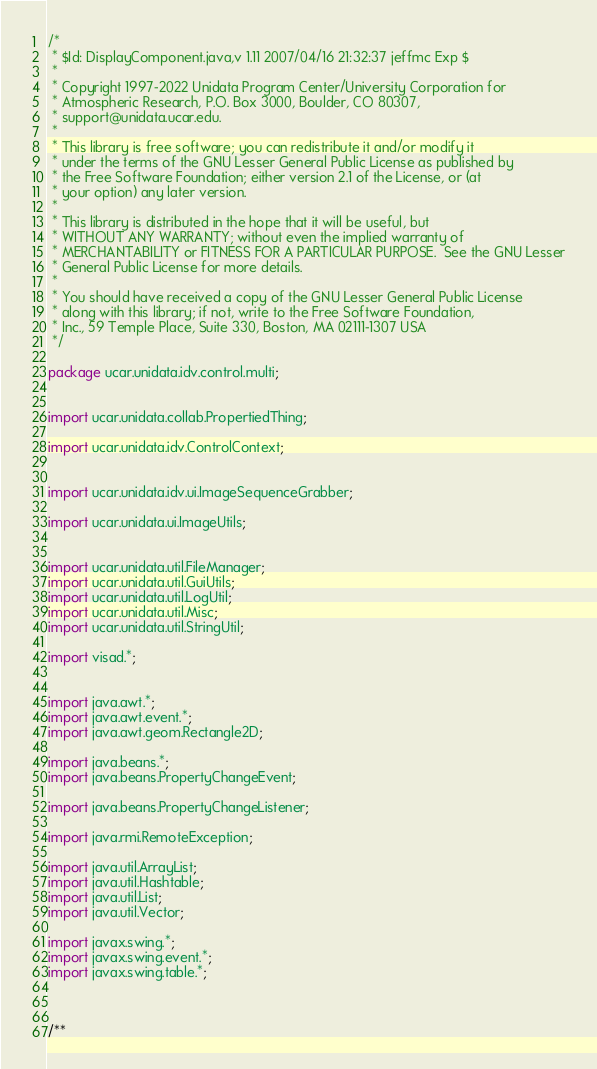Convert code to text. <code><loc_0><loc_0><loc_500><loc_500><_Java_>/*
 * $Id: DisplayComponent.java,v 1.11 2007/04/16 21:32:37 jeffmc Exp $
 *
 * Copyright 1997-2022 Unidata Program Center/University Corporation for
 * Atmospheric Research, P.O. Box 3000, Boulder, CO 80307,
 * support@unidata.ucar.edu.
 *
 * This library is free software; you can redistribute it and/or modify it
 * under the terms of the GNU Lesser General Public License as published by
 * the Free Software Foundation; either version 2.1 of the License, or (at
 * your option) any later version.
 *
 * This library is distributed in the hope that it will be useful, but
 * WITHOUT ANY WARRANTY; without even the implied warranty of
 * MERCHANTABILITY or FITNESS FOR A PARTICULAR PURPOSE.  See the GNU Lesser
 * General Public License for more details.
 *
 * You should have received a copy of the GNU Lesser General Public License
 * along with this library; if not, write to the Free Software Foundation,
 * Inc., 59 Temple Place, Suite 330, Boston, MA 02111-1307 USA
 */

package ucar.unidata.idv.control.multi;


import ucar.unidata.collab.PropertiedThing;

import ucar.unidata.idv.ControlContext;


import ucar.unidata.idv.ui.ImageSequenceGrabber;

import ucar.unidata.ui.ImageUtils;


import ucar.unidata.util.FileManager;
import ucar.unidata.util.GuiUtils;
import ucar.unidata.util.LogUtil;
import ucar.unidata.util.Misc;
import ucar.unidata.util.StringUtil;

import visad.*;


import java.awt.*;
import java.awt.event.*;
import java.awt.geom.Rectangle2D;

import java.beans.*;
import java.beans.PropertyChangeEvent;

import java.beans.PropertyChangeListener;

import java.rmi.RemoteException;

import java.util.ArrayList;
import java.util.Hashtable;
import java.util.List;
import java.util.Vector;

import javax.swing.*;
import javax.swing.event.*;
import javax.swing.table.*;



/**</code> 